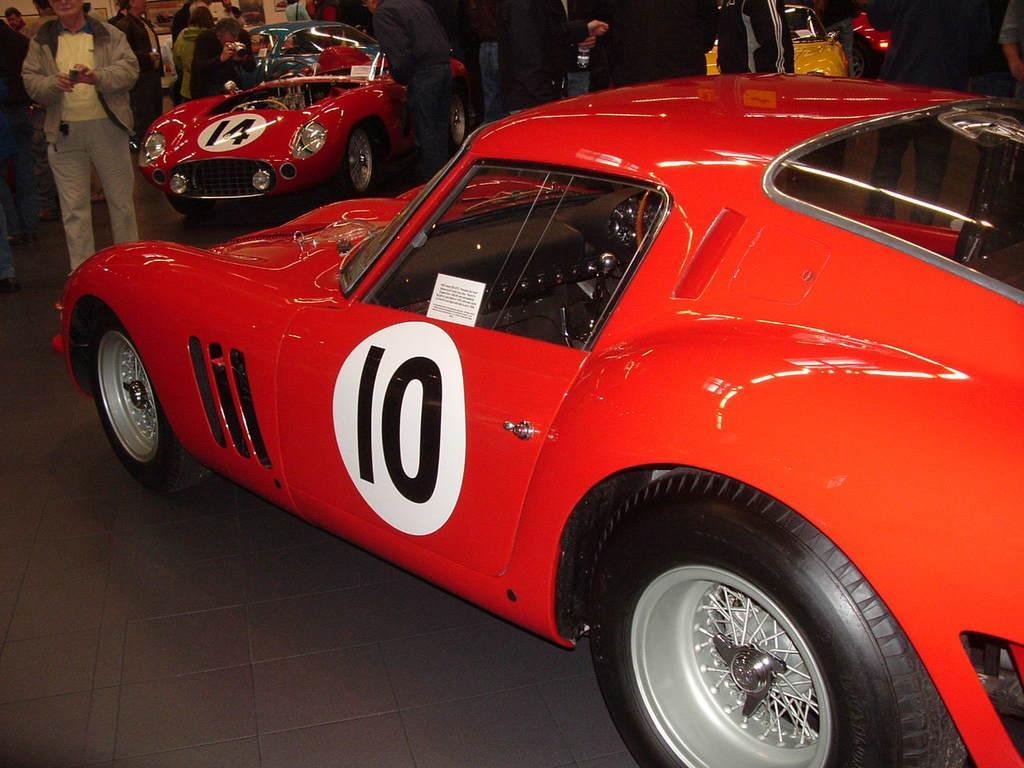Can you describe this image briefly? The picture consists of people red color cars and yellow car. The picture is taken in a car exhibition. 